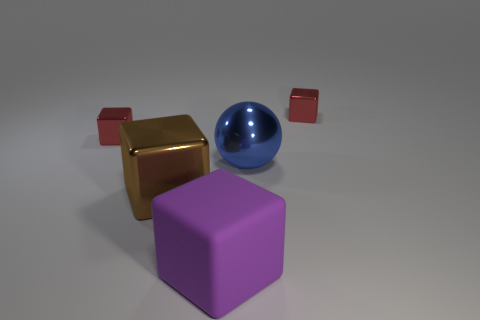What shape is the blue object that is made of the same material as the large brown thing?
Make the answer very short. Sphere. What is the color of the other metal object that is the same size as the blue object?
Ensure brevity in your answer.  Brown. There is a metallic thing left of the brown shiny object; does it have the same size as the large brown cube?
Give a very brief answer. No. Is the color of the large metal cube the same as the ball?
Make the answer very short. No. What number of large brown metal cubes are there?
Your answer should be very brief. 1. How many cylinders are either purple objects or red metal things?
Ensure brevity in your answer.  0. What number of large brown things are behind the red metal block that is on the left side of the big brown thing?
Provide a succinct answer. 0. Does the purple cube have the same material as the ball?
Provide a short and direct response. No. Is there a big green ball made of the same material as the blue ball?
Keep it short and to the point. No. What color is the small cube in front of the tiny red cube behind the tiny red shiny block left of the large brown cube?
Your answer should be very brief. Red. 